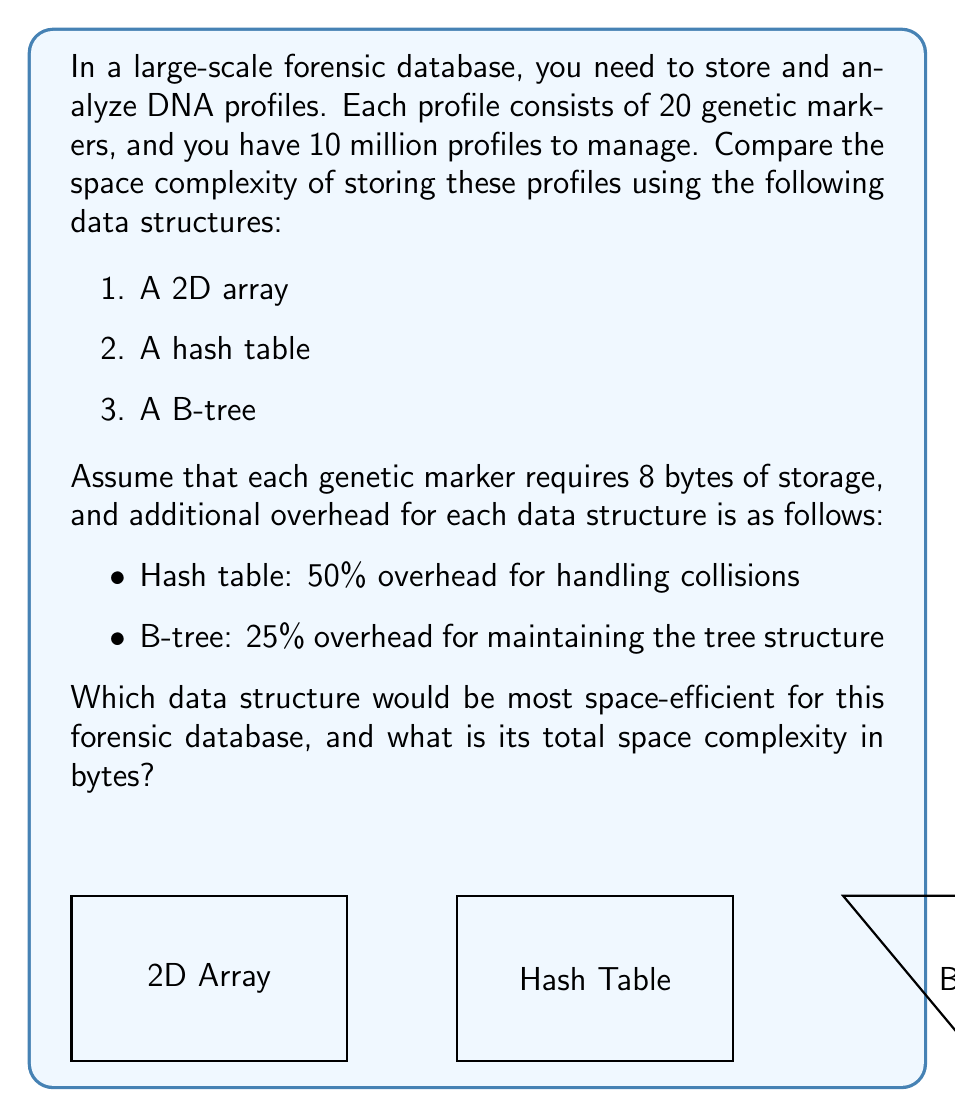Help me with this question. Let's analyze the space complexity of each data structure:

1. 2D Array:
   - Space for data: $10,000,000 \times 20 \times 8 = 1,600,000,000$ bytes
   - No additional overhead
   - Total: $1,600,000,000$ bytes

2. Hash Table:
   - Space for data: $1,600,000,000$ bytes
   - Overhead: $50\% \times 1,600,000,000 = 800,000,000$ bytes
   - Total: $1,600,000,000 + 800,000,000 = 2,400,000,000$ bytes

3. B-tree:
   - Space for data: $1,600,000,000$ bytes
   - Overhead: $25\% \times 1,600,000,000 = 400,000,000$ bytes
   - Total: $1,600,000,000 + 400,000,000 = 2,000,000,000$ bytes

Comparing the total space requirements:
- 2D Array: $1,600,000,000$ bytes
- Hash Table: $2,400,000,000$ bytes
- B-tree: $2,000,000,000$ bytes

The 2D array is the most space-efficient data structure for this forensic database.

The space complexity can be expressed as $O(nm)$, where $n$ is the number of profiles (10 million) and $m$ is the number of genetic markers per profile (20).

Total space complexity in bytes: $10,000,000 \times 20 \times 8 = 1,600,000,000$ bytes
Answer: 2D array; $O(nm)$; 1,600,000,000 bytes 